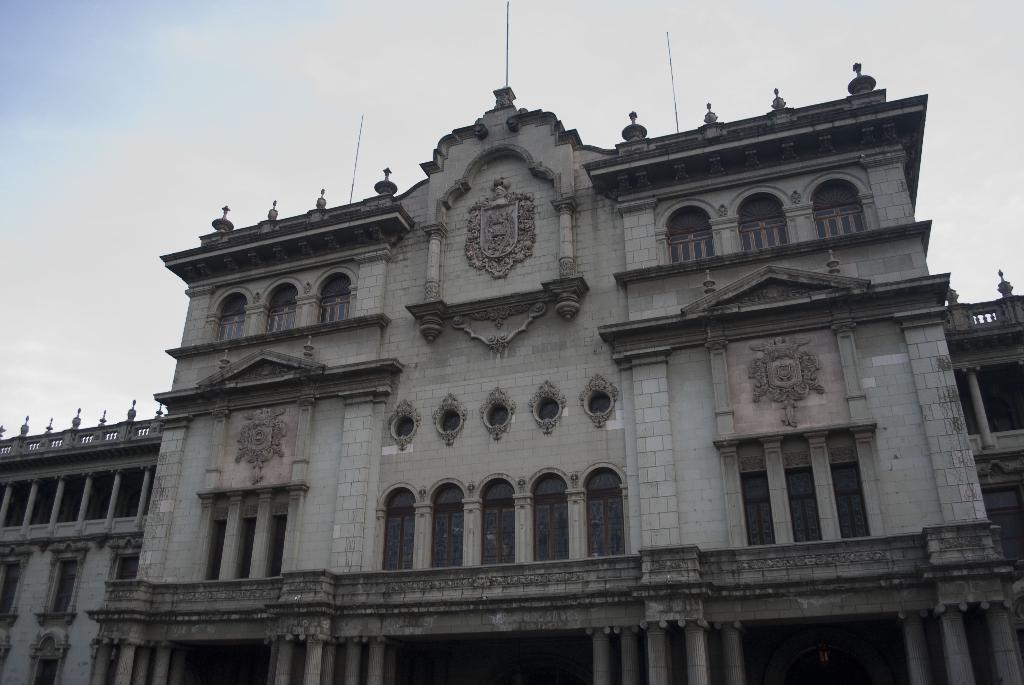Describe this image in one or two sentences. This picture is clicked outside. In the center we can see the building and we can see the windows and pillars of the building. In the background there is a sky. 